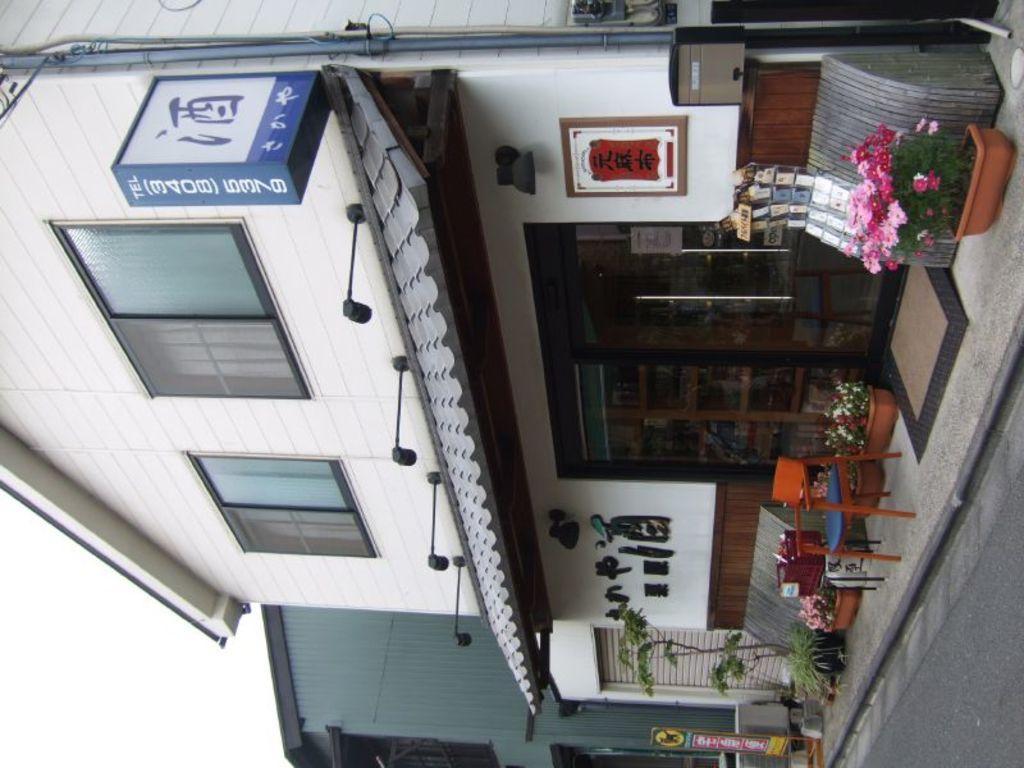Could you give a brief overview of what you see in this image? This image is taken in outdoors. In the right side of the image there is a road and flower pot with a plant in it. In this image there is a house with windows and door, beside that there is a building. In the middle of the image there is a sign board. 